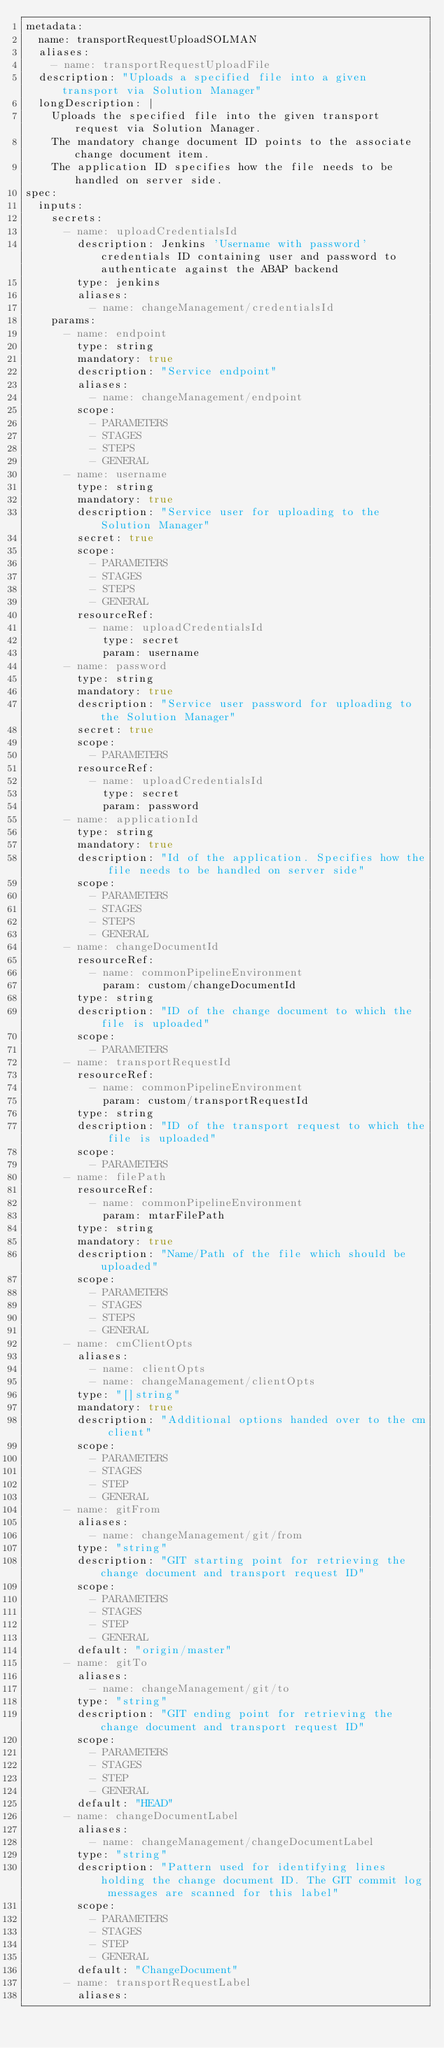Convert code to text. <code><loc_0><loc_0><loc_500><loc_500><_YAML_>metadata:
  name: transportRequestUploadSOLMAN
  aliases:
    - name: transportRequestUploadFile
  description: "Uploads a specified file into a given transport via Solution Manager"
  longDescription: |
    Uploads the specified file into the given transport request via Solution Manager.
    The mandatory change document ID points to the associate change document item.
    The application ID specifies how the file needs to be handled on server side.
spec:
  inputs:
    secrets:
      - name: uploadCredentialsId
        description: Jenkins 'Username with password' credentials ID containing user and password to authenticate against the ABAP backend
        type: jenkins
        aliases:
          - name: changeManagement/credentialsId
    params:
      - name: endpoint
        type: string
        mandatory: true
        description: "Service endpoint"
        aliases:
          - name: changeManagement/endpoint
        scope:
          - PARAMETERS
          - STAGES
          - STEPS
          - GENERAL
      - name: username
        type: string
        mandatory: true
        description: "Service user for uploading to the Solution Manager"
        secret: true
        scope:
          - PARAMETERS
          - STAGES
          - STEPS
          - GENERAL
        resourceRef:
          - name: uploadCredentialsId
            type: secret
            param: username
      - name: password
        type: string
        mandatory: true
        description: "Service user password for uploading to the Solution Manager"
        secret: true
        scope:
          - PARAMETERS
        resourceRef:
          - name: uploadCredentialsId
            type: secret
            param: password
      - name: applicationId
        type: string
        mandatory: true
        description: "Id of the application. Specifies how the file needs to be handled on server side"
        scope:
          - PARAMETERS
          - STAGES
          - STEPS
          - GENERAL
      - name: changeDocumentId
        resourceRef:
          - name: commonPipelineEnvironment
            param: custom/changeDocumentId
        type: string
        description: "ID of the change document to which the file is uploaded"
        scope:
          - PARAMETERS
      - name: transportRequestId
        resourceRef:
          - name: commonPipelineEnvironment
            param: custom/transportRequestId
        type: string
        description: "ID of the transport request to which the file is uploaded"
        scope:
          - PARAMETERS
      - name: filePath
        resourceRef:
          - name: commonPipelineEnvironment
            param: mtarFilePath
        type: string
        mandatory: true
        description: "Name/Path of the file which should be uploaded"
        scope:
          - PARAMETERS
          - STAGES
          - STEPS
          - GENERAL
      - name: cmClientOpts
        aliases:
          - name: clientOpts
          - name: changeManagement/clientOpts
        type: "[]string"
        mandatory: true
        description: "Additional options handed over to the cm client"
        scope:
          - PARAMETERS
          - STAGES
          - STEP
          - GENERAL
      - name: gitFrom
        aliases:
          - name: changeManagement/git/from
        type: "string"
        description: "GIT starting point for retrieving the change document and transport request ID"
        scope:
          - PARAMETERS
          - STAGES
          - STEP
          - GENERAL
        default: "origin/master"
      - name: gitTo
        aliases:
          - name: changeManagement/git/to
        type: "string"
        description: "GIT ending point for retrieving the change document and transport request ID"
        scope:
          - PARAMETERS
          - STAGES
          - STEP
          - GENERAL
        default: "HEAD"
      - name: changeDocumentLabel
        aliases:
          - name: changeManagement/changeDocumentLabel
        type: "string"
        description: "Pattern used for identifying lines holding the change document ID. The GIT commit log messages are scanned for this label"
        scope:
          - PARAMETERS
          - STAGES
          - STEP
          - GENERAL
        default: "ChangeDocument"
      - name: transportRequestLabel
        aliases:</code> 